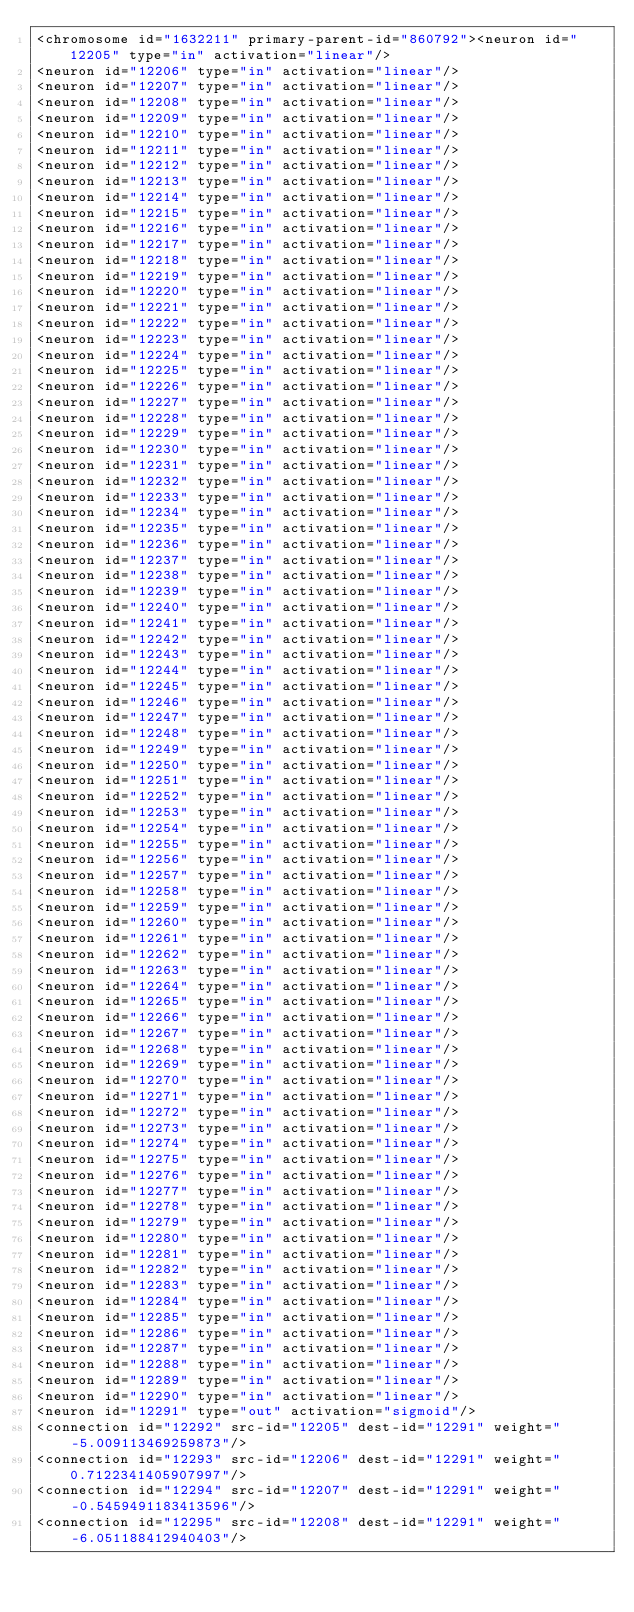Convert code to text. <code><loc_0><loc_0><loc_500><loc_500><_XML_><chromosome id="1632211" primary-parent-id="860792"><neuron id="12205" type="in" activation="linear"/>
<neuron id="12206" type="in" activation="linear"/>
<neuron id="12207" type="in" activation="linear"/>
<neuron id="12208" type="in" activation="linear"/>
<neuron id="12209" type="in" activation="linear"/>
<neuron id="12210" type="in" activation="linear"/>
<neuron id="12211" type="in" activation="linear"/>
<neuron id="12212" type="in" activation="linear"/>
<neuron id="12213" type="in" activation="linear"/>
<neuron id="12214" type="in" activation="linear"/>
<neuron id="12215" type="in" activation="linear"/>
<neuron id="12216" type="in" activation="linear"/>
<neuron id="12217" type="in" activation="linear"/>
<neuron id="12218" type="in" activation="linear"/>
<neuron id="12219" type="in" activation="linear"/>
<neuron id="12220" type="in" activation="linear"/>
<neuron id="12221" type="in" activation="linear"/>
<neuron id="12222" type="in" activation="linear"/>
<neuron id="12223" type="in" activation="linear"/>
<neuron id="12224" type="in" activation="linear"/>
<neuron id="12225" type="in" activation="linear"/>
<neuron id="12226" type="in" activation="linear"/>
<neuron id="12227" type="in" activation="linear"/>
<neuron id="12228" type="in" activation="linear"/>
<neuron id="12229" type="in" activation="linear"/>
<neuron id="12230" type="in" activation="linear"/>
<neuron id="12231" type="in" activation="linear"/>
<neuron id="12232" type="in" activation="linear"/>
<neuron id="12233" type="in" activation="linear"/>
<neuron id="12234" type="in" activation="linear"/>
<neuron id="12235" type="in" activation="linear"/>
<neuron id="12236" type="in" activation="linear"/>
<neuron id="12237" type="in" activation="linear"/>
<neuron id="12238" type="in" activation="linear"/>
<neuron id="12239" type="in" activation="linear"/>
<neuron id="12240" type="in" activation="linear"/>
<neuron id="12241" type="in" activation="linear"/>
<neuron id="12242" type="in" activation="linear"/>
<neuron id="12243" type="in" activation="linear"/>
<neuron id="12244" type="in" activation="linear"/>
<neuron id="12245" type="in" activation="linear"/>
<neuron id="12246" type="in" activation="linear"/>
<neuron id="12247" type="in" activation="linear"/>
<neuron id="12248" type="in" activation="linear"/>
<neuron id="12249" type="in" activation="linear"/>
<neuron id="12250" type="in" activation="linear"/>
<neuron id="12251" type="in" activation="linear"/>
<neuron id="12252" type="in" activation="linear"/>
<neuron id="12253" type="in" activation="linear"/>
<neuron id="12254" type="in" activation="linear"/>
<neuron id="12255" type="in" activation="linear"/>
<neuron id="12256" type="in" activation="linear"/>
<neuron id="12257" type="in" activation="linear"/>
<neuron id="12258" type="in" activation="linear"/>
<neuron id="12259" type="in" activation="linear"/>
<neuron id="12260" type="in" activation="linear"/>
<neuron id="12261" type="in" activation="linear"/>
<neuron id="12262" type="in" activation="linear"/>
<neuron id="12263" type="in" activation="linear"/>
<neuron id="12264" type="in" activation="linear"/>
<neuron id="12265" type="in" activation="linear"/>
<neuron id="12266" type="in" activation="linear"/>
<neuron id="12267" type="in" activation="linear"/>
<neuron id="12268" type="in" activation="linear"/>
<neuron id="12269" type="in" activation="linear"/>
<neuron id="12270" type="in" activation="linear"/>
<neuron id="12271" type="in" activation="linear"/>
<neuron id="12272" type="in" activation="linear"/>
<neuron id="12273" type="in" activation="linear"/>
<neuron id="12274" type="in" activation="linear"/>
<neuron id="12275" type="in" activation="linear"/>
<neuron id="12276" type="in" activation="linear"/>
<neuron id="12277" type="in" activation="linear"/>
<neuron id="12278" type="in" activation="linear"/>
<neuron id="12279" type="in" activation="linear"/>
<neuron id="12280" type="in" activation="linear"/>
<neuron id="12281" type="in" activation="linear"/>
<neuron id="12282" type="in" activation="linear"/>
<neuron id="12283" type="in" activation="linear"/>
<neuron id="12284" type="in" activation="linear"/>
<neuron id="12285" type="in" activation="linear"/>
<neuron id="12286" type="in" activation="linear"/>
<neuron id="12287" type="in" activation="linear"/>
<neuron id="12288" type="in" activation="linear"/>
<neuron id="12289" type="in" activation="linear"/>
<neuron id="12290" type="in" activation="linear"/>
<neuron id="12291" type="out" activation="sigmoid"/>
<connection id="12292" src-id="12205" dest-id="12291" weight="-5.009113469259873"/>
<connection id="12293" src-id="12206" dest-id="12291" weight="0.7122341405907997"/>
<connection id="12294" src-id="12207" dest-id="12291" weight="-0.5459491183413596"/>
<connection id="12295" src-id="12208" dest-id="12291" weight="-6.051188412940403"/></code> 